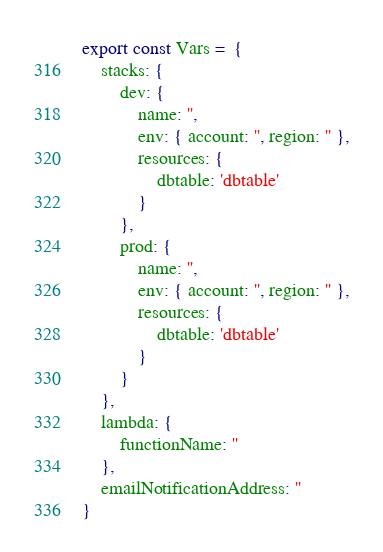<code> <loc_0><loc_0><loc_500><loc_500><_TypeScript_>export const Vars =  {
    stacks: {
        dev: {
            name: '',
            env: { account: '', region: '' },
            resources: {
                dbtable: 'dbtable'
            }
        },
        prod: {
            name: '',
            env: { account: '', region: '' },
            resources: {
                dbtable: 'dbtable'
            }
        }
    },
    lambda: {
        functionName: ''
    },
    emailNotificationAddress: ''
}</code> 